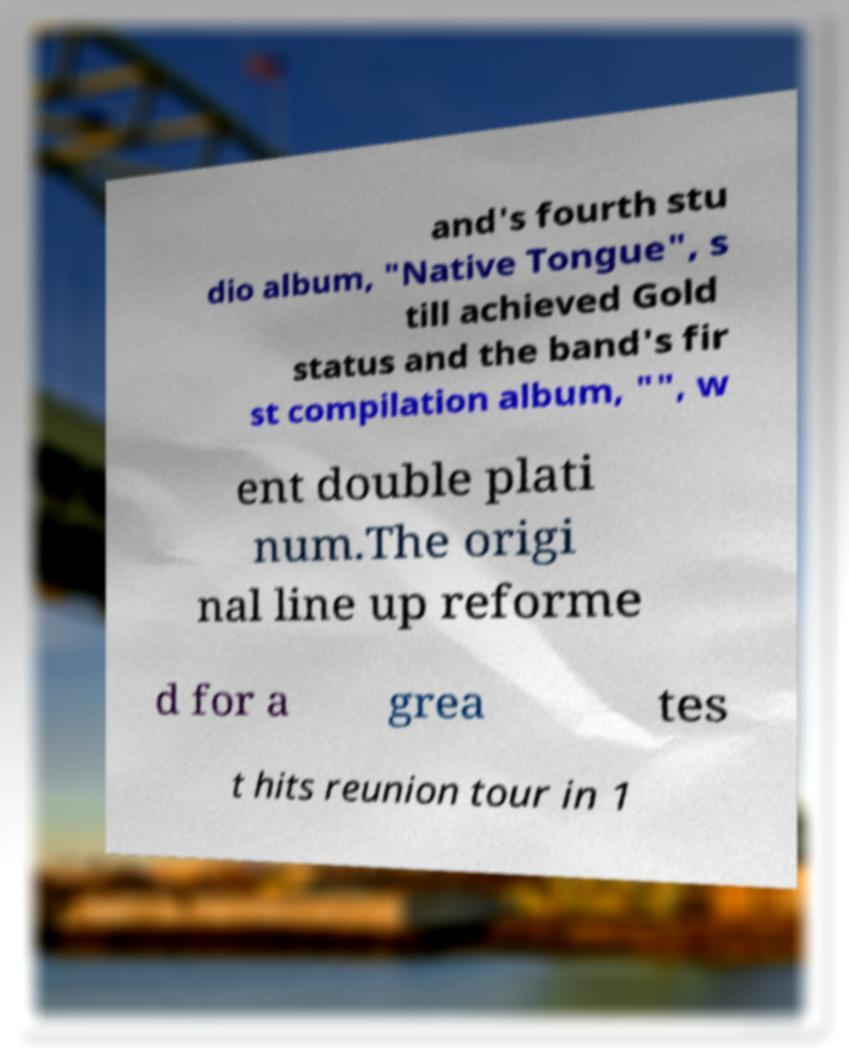Please identify and transcribe the text found in this image. and's fourth stu dio album, "Native Tongue", s till achieved Gold status and the band's fir st compilation album, "", w ent double plati num.The origi nal line up reforme d for a grea tes t hits reunion tour in 1 